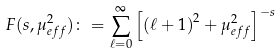<formula> <loc_0><loc_0><loc_500><loc_500>F ( s , \mu _ { e f f } ^ { 2 } ) \colon = \sum _ { \ell = 0 } ^ { \infty } \left [ \left ( \ell + 1 \right ) ^ { 2 } + \mu _ { e f f } ^ { 2 } \right ] ^ { - s }</formula> 